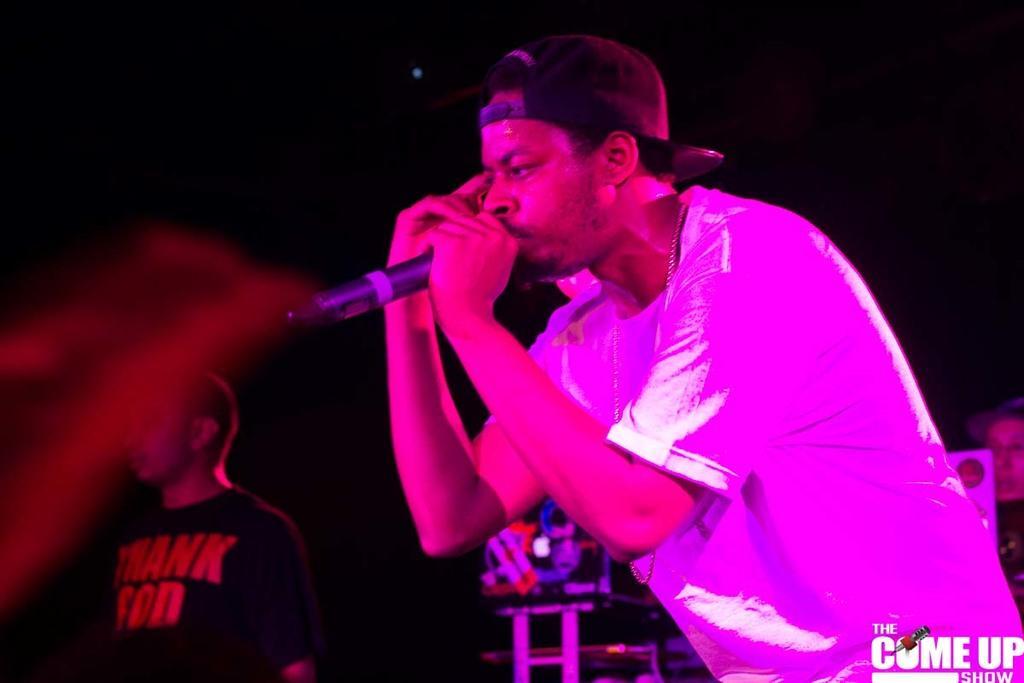Can you describe this image briefly? In this image I can see a person holding a mike and in the background I can see dark view and I can see another person at the bottom and I can see a person on the right side. 